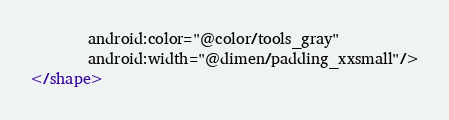<code> <loc_0><loc_0><loc_500><loc_500><_XML_>        android:color="@color/tools_gray"
        android:width="@dimen/padding_xxsmall"/>
</shape>
</code> 